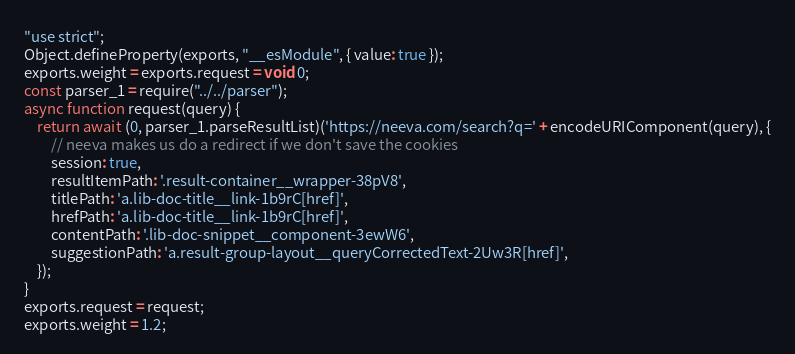<code> <loc_0><loc_0><loc_500><loc_500><_JavaScript_>"use strict";
Object.defineProperty(exports, "__esModule", { value: true });
exports.weight = exports.request = void 0;
const parser_1 = require("../../parser");
async function request(query) {
    return await (0, parser_1.parseResultList)('https://neeva.com/search?q=' + encodeURIComponent(query), {
        // neeva makes us do a redirect if we don't save the cookies
        session: true,
        resultItemPath: '.result-container__wrapper-38pV8',
        titlePath: 'a.lib-doc-title__link-1b9rC[href]',
        hrefPath: 'a.lib-doc-title__link-1b9rC[href]',
        contentPath: '.lib-doc-snippet__component-3ewW6',
        suggestionPath: 'a.result-group-layout__queryCorrectedText-2Uw3R[href]',
    });
}
exports.request = request;
exports.weight = 1.2;
</code> 